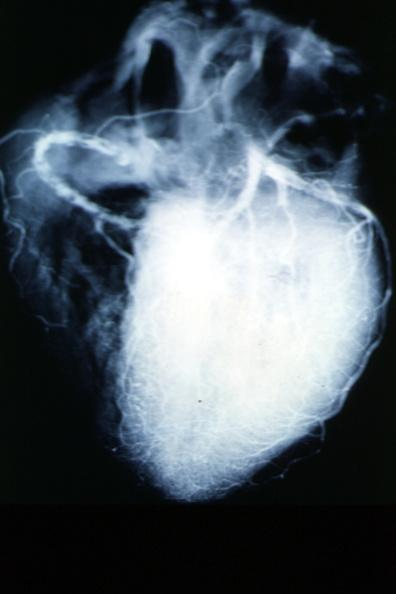s cardiovascular present?
Answer the question using a single word or phrase. Yes 